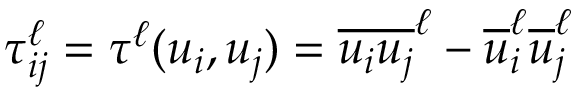Convert formula to latex. <formula><loc_0><loc_0><loc_500><loc_500>\tau _ { i j } ^ { \ell } = \tau ^ { \ell } ( u _ { i } , u _ { j } ) = \overline { { u _ { i } u _ { j } } } ^ { \ell } - \overline { u } _ { i } ^ { \ell } \overline { u } _ { j } ^ { \ell }</formula> 